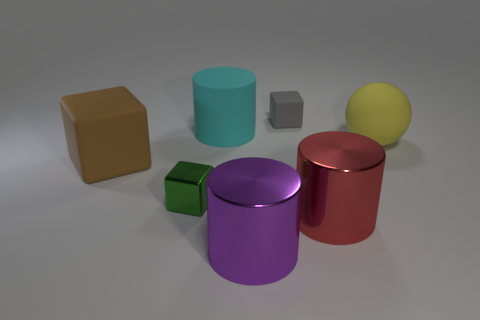Add 2 tiny yellow balls. How many objects exist? 9 Subtract all spheres. How many objects are left? 6 Subtract all shiny things. Subtract all big red metal objects. How many objects are left? 3 Add 3 big blocks. How many big blocks are left? 4 Add 7 big brown matte objects. How many big brown matte objects exist? 8 Subtract 0 green cylinders. How many objects are left? 7 